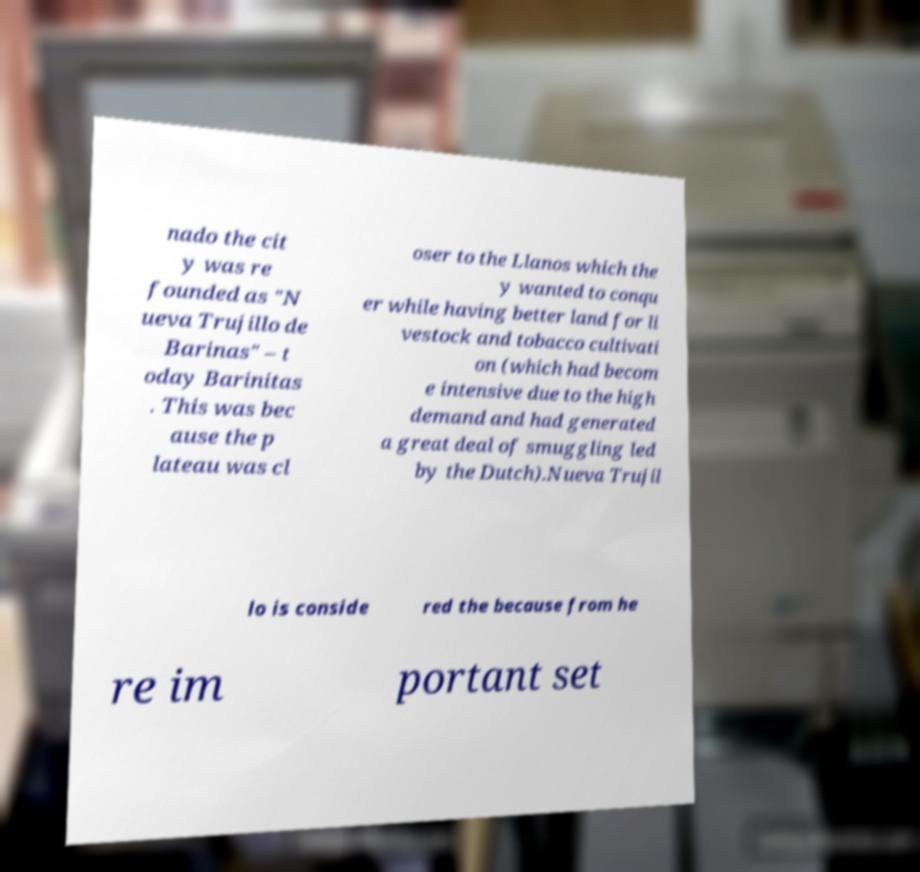I need the written content from this picture converted into text. Can you do that? nado the cit y was re founded as "N ueva Trujillo de Barinas" – t oday Barinitas . This was bec ause the p lateau was cl oser to the Llanos which the y wanted to conqu er while having better land for li vestock and tobacco cultivati on (which had becom e intensive due to the high demand and had generated a great deal of smuggling led by the Dutch).Nueva Trujil lo is conside red the because from he re im portant set 